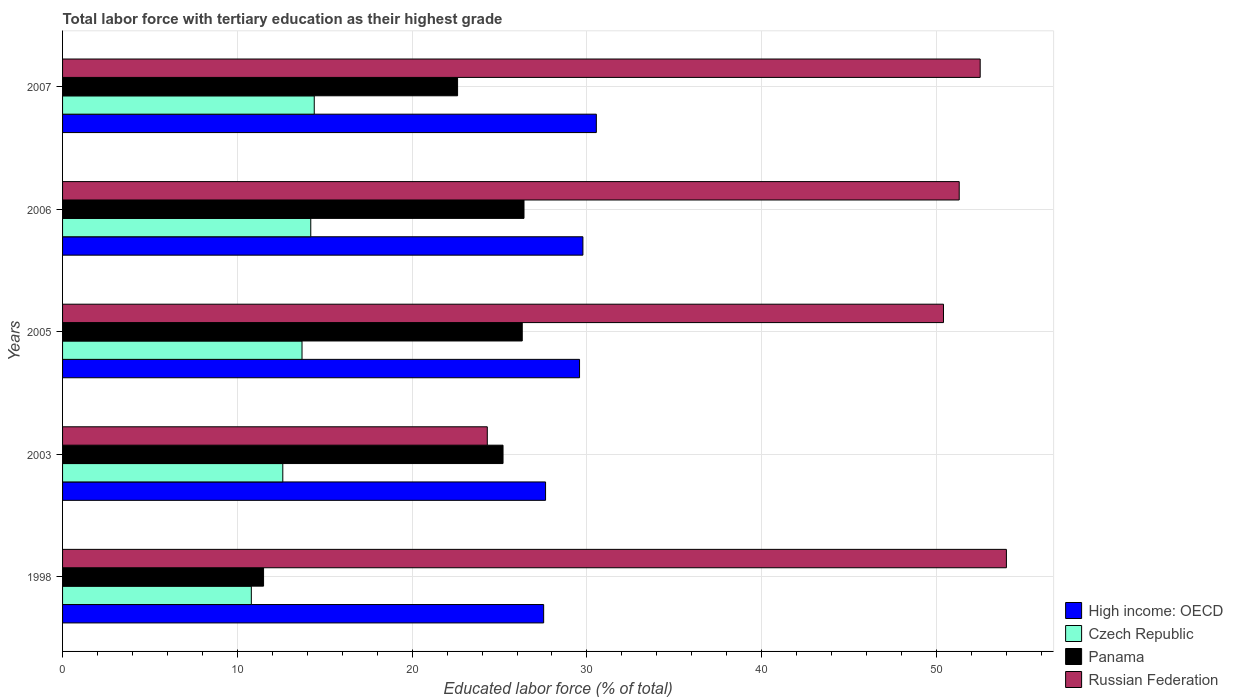How many different coloured bars are there?
Your response must be concise. 4. Are the number of bars on each tick of the Y-axis equal?
Give a very brief answer. Yes. How many bars are there on the 3rd tick from the top?
Make the answer very short. 4. What is the label of the 4th group of bars from the top?
Your answer should be compact. 2003. What is the percentage of male labor force with tertiary education in Russian Federation in 2006?
Your answer should be very brief. 51.3. Across all years, what is the maximum percentage of male labor force with tertiary education in Panama?
Provide a short and direct response. 26.4. Across all years, what is the minimum percentage of male labor force with tertiary education in Czech Republic?
Provide a succinct answer. 10.8. In which year was the percentage of male labor force with tertiary education in Panama minimum?
Give a very brief answer. 1998. What is the total percentage of male labor force with tertiary education in High income: OECD in the graph?
Ensure brevity in your answer.  145.04. What is the difference between the percentage of male labor force with tertiary education in High income: OECD in 1998 and that in 2006?
Give a very brief answer. -2.25. What is the difference between the percentage of male labor force with tertiary education in Panama in 2006 and the percentage of male labor force with tertiary education in Czech Republic in 2005?
Give a very brief answer. 12.7. What is the average percentage of male labor force with tertiary education in Czech Republic per year?
Ensure brevity in your answer.  13.14. In the year 1998, what is the difference between the percentage of male labor force with tertiary education in Panama and percentage of male labor force with tertiary education in Russian Federation?
Offer a very short reply. -42.5. What is the ratio of the percentage of male labor force with tertiary education in Russian Federation in 2003 to that in 2006?
Make the answer very short. 0.47. Is the percentage of male labor force with tertiary education in Czech Republic in 1998 less than that in 2005?
Your answer should be compact. Yes. Is the difference between the percentage of male labor force with tertiary education in Panama in 1998 and 2006 greater than the difference between the percentage of male labor force with tertiary education in Russian Federation in 1998 and 2006?
Your response must be concise. No. What is the difference between the highest and the second highest percentage of male labor force with tertiary education in Czech Republic?
Offer a very short reply. 0.2. What is the difference between the highest and the lowest percentage of male labor force with tertiary education in Czech Republic?
Provide a succinct answer. 3.6. Is the sum of the percentage of male labor force with tertiary education in Russian Federation in 2003 and 2007 greater than the maximum percentage of male labor force with tertiary education in Czech Republic across all years?
Your response must be concise. Yes. Is it the case that in every year, the sum of the percentage of male labor force with tertiary education in Panama and percentage of male labor force with tertiary education in High income: OECD is greater than the sum of percentage of male labor force with tertiary education in Russian Federation and percentage of male labor force with tertiary education in Czech Republic?
Ensure brevity in your answer.  No. What does the 2nd bar from the top in 2005 represents?
Offer a very short reply. Panama. What does the 2nd bar from the bottom in 2003 represents?
Provide a succinct answer. Czech Republic. Is it the case that in every year, the sum of the percentage of male labor force with tertiary education in Czech Republic and percentage of male labor force with tertiary education in Russian Federation is greater than the percentage of male labor force with tertiary education in High income: OECD?
Provide a short and direct response. Yes. How many years are there in the graph?
Give a very brief answer. 5. Where does the legend appear in the graph?
Ensure brevity in your answer.  Bottom right. How many legend labels are there?
Offer a very short reply. 4. How are the legend labels stacked?
Provide a short and direct response. Vertical. What is the title of the graph?
Provide a succinct answer. Total labor force with tertiary education as their highest grade. Does "St. Lucia" appear as one of the legend labels in the graph?
Provide a succinct answer. No. What is the label or title of the X-axis?
Make the answer very short. Educated labor force (% of total). What is the label or title of the Y-axis?
Offer a terse response. Years. What is the Educated labor force (% of total) in High income: OECD in 1998?
Ensure brevity in your answer.  27.52. What is the Educated labor force (% of total) in Czech Republic in 1998?
Keep it short and to the point. 10.8. What is the Educated labor force (% of total) in Panama in 1998?
Your response must be concise. 11.5. What is the Educated labor force (% of total) of Russian Federation in 1998?
Make the answer very short. 54. What is the Educated labor force (% of total) in High income: OECD in 2003?
Provide a short and direct response. 27.63. What is the Educated labor force (% of total) of Czech Republic in 2003?
Provide a short and direct response. 12.6. What is the Educated labor force (% of total) of Panama in 2003?
Provide a short and direct response. 25.2. What is the Educated labor force (% of total) of Russian Federation in 2003?
Make the answer very short. 24.3. What is the Educated labor force (% of total) in High income: OECD in 2005?
Offer a terse response. 29.58. What is the Educated labor force (% of total) in Czech Republic in 2005?
Provide a succinct answer. 13.7. What is the Educated labor force (% of total) of Panama in 2005?
Make the answer very short. 26.3. What is the Educated labor force (% of total) in Russian Federation in 2005?
Offer a terse response. 50.4. What is the Educated labor force (% of total) of High income: OECD in 2006?
Make the answer very short. 29.77. What is the Educated labor force (% of total) in Czech Republic in 2006?
Make the answer very short. 14.2. What is the Educated labor force (% of total) of Panama in 2006?
Your response must be concise. 26.4. What is the Educated labor force (% of total) of Russian Federation in 2006?
Provide a short and direct response. 51.3. What is the Educated labor force (% of total) in High income: OECD in 2007?
Offer a terse response. 30.54. What is the Educated labor force (% of total) of Czech Republic in 2007?
Ensure brevity in your answer.  14.4. What is the Educated labor force (% of total) of Panama in 2007?
Keep it short and to the point. 22.6. What is the Educated labor force (% of total) of Russian Federation in 2007?
Your response must be concise. 52.5. Across all years, what is the maximum Educated labor force (% of total) in High income: OECD?
Provide a succinct answer. 30.54. Across all years, what is the maximum Educated labor force (% of total) in Czech Republic?
Your answer should be compact. 14.4. Across all years, what is the maximum Educated labor force (% of total) in Panama?
Your answer should be very brief. 26.4. Across all years, what is the maximum Educated labor force (% of total) in Russian Federation?
Your answer should be very brief. 54. Across all years, what is the minimum Educated labor force (% of total) in High income: OECD?
Provide a succinct answer. 27.52. Across all years, what is the minimum Educated labor force (% of total) in Czech Republic?
Your response must be concise. 10.8. Across all years, what is the minimum Educated labor force (% of total) of Russian Federation?
Provide a short and direct response. 24.3. What is the total Educated labor force (% of total) of High income: OECD in the graph?
Provide a succinct answer. 145.04. What is the total Educated labor force (% of total) of Czech Republic in the graph?
Offer a terse response. 65.7. What is the total Educated labor force (% of total) in Panama in the graph?
Give a very brief answer. 112. What is the total Educated labor force (% of total) of Russian Federation in the graph?
Your answer should be compact. 232.5. What is the difference between the Educated labor force (% of total) of High income: OECD in 1998 and that in 2003?
Your response must be concise. -0.11. What is the difference between the Educated labor force (% of total) of Panama in 1998 and that in 2003?
Your answer should be very brief. -13.7. What is the difference between the Educated labor force (% of total) in Russian Federation in 1998 and that in 2003?
Give a very brief answer. 29.7. What is the difference between the Educated labor force (% of total) in High income: OECD in 1998 and that in 2005?
Offer a very short reply. -2.05. What is the difference between the Educated labor force (% of total) of Czech Republic in 1998 and that in 2005?
Give a very brief answer. -2.9. What is the difference between the Educated labor force (% of total) in Panama in 1998 and that in 2005?
Your answer should be very brief. -14.8. What is the difference between the Educated labor force (% of total) in Russian Federation in 1998 and that in 2005?
Offer a terse response. 3.6. What is the difference between the Educated labor force (% of total) in High income: OECD in 1998 and that in 2006?
Make the answer very short. -2.25. What is the difference between the Educated labor force (% of total) of Panama in 1998 and that in 2006?
Make the answer very short. -14.9. What is the difference between the Educated labor force (% of total) of High income: OECD in 1998 and that in 2007?
Provide a succinct answer. -3.01. What is the difference between the Educated labor force (% of total) of High income: OECD in 2003 and that in 2005?
Provide a succinct answer. -1.94. What is the difference between the Educated labor force (% of total) of Panama in 2003 and that in 2005?
Keep it short and to the point. -1.1. What is the difference between the Educated labor force (% of total) of Russian Federation in 2003 and that in 2005?
Ensure brevity in your answer.  -26.1. What is the difference between the Educated labor force (% of total) of High income: OECD in 2003 and that in 2006?
Make the answer very short. -2.14. What is the difference between the Educated labor force (% of total) of Czech Republic in 2003 and that in 2006?
Provide a succinct answer. -1.6. What is the difference between the Educated labor force (% of total) of Russian Federation in 2003 and that in 2006?
Offer a very short reply. -27. What is the difference between the Educated labor force (% of total) in High income: OECD in 2003 and that in 2007?
Make the answer very short. -2.9. What is the difference between the Educated labor force (% of total) in Czech Republic in 2003 and that in 2007?
Your answer should be very brief. -1.8. What is the difference between the Educated labor force (% of total) in Panama in 2003 and that in 2007?
Offer a terse response. 2.6. What is the difference between the Educated labor force (% of total) in Russian Federation in 2003 and that in 2007?
Make the answer very short. -28.2. What is the difference between the Educated labor force (% of total) of High income: OECD in 2005 and that in 2006?
Your answer should be compact. -0.19. What is the difference between the Educated labor force (% of total) of Czech Republic in 2005 and that in 2006?
Provide a short and direct response. -0.5. What is the difference between the Educated labor force (% of total) in Panama in 2005 and that in 2006?
Offer a terse response. -0.1. What is the difference between the Educated labor force (% of total) in Russian Federation in 2005 and that in 2006?
Make the answer very short. -0.9. What is the difference between the Educated labor force (% of total) in High income: OECD in 2005 and that in 2007?
Give a very brief answer. -0.96. What is the difference between the Educated labor force (% of total) in Czech Republic in 2005 and that in 2007?
Keep it short and to the point. -0.7. What is the difference between the Educated labor force (% of total) of Panama in 2005 and that in 2007?
Give a very brief answer. 3.7. What is the difference between the Educated labor force (% of total) in Russian Federation in 2005 and that in 2007?
Offer a very short reply. -2.1. What is the difference between the Educated labor force (% of total) in High income: OECD in 2006 and that in 2007?
Your answer should be very brief. -0.77. What is the difference between the Educated labor force (% of total) in Czech Republic in 2006 and that in 2007?
Your answer should be very brief. -0.2. What is the difference between the Educated labor force (% of total) of Panama in 2006 and that in 2007?
Keep it short and to the point. 3.8. What is the difference between the Educated labor force (% of total) of Russian Federation in 2006 and that in 2007?
Make the answer very short. -1.2. What is the difference between the Educated labor force (% of total) of High income: OECD in 1998 and the Educated labor force (% of total) of Czech Republic in 2003?
Provide a short and direct response. 14.92. What is the difference between the Educated labor force (% of total) in High income: OECD in 1998 and the Educated labor force (% of total) in Panama in 2003?
Offer a very short reply. 2.32. What is the difference between the Educated labor force (% of total) of High income: OECD in 1998 and the Educated labor force (% of total) of Russian Federation in 2003?
Make the answer very short. 3.22. What is the difference between the Educated labor force (% of total) of Czech Republic in 1998 and the Educated labor force (% of total) of Panama in 2003?
Ensure brevity in your answer.  -14.4. What is the difference between the Educated labor force (% of total) of High income: OECD in 1998 and the Educated labor force (% of total) of Czech Republic in 2005?
Offer a terse response. 13.82. What is the difference between the Educated labor force (% of total) in High income: OECD in 1998 and the Educated labor force (% of total) in Panama in 2005?
Offer a terse response. 1.22. What is the difference between the Educated labor force (% of total) of High income: OECD in 1998 and the Educated labor force (% of total) of Russian Federation in 2005?
Provide a succinct answer. -22.88. What is the difference between the Educated labor force (% of total) of Czech Republic in 1998 and the Educated labor force (% of total) of Panama in 2005?
Provide a succinct answer. -15.5. What is the difference between the Educated labor force (% of total) of Czech Republic in 1998 and the Educated labor force (% of total) of Russian Federation in 2005?
Your response must be concise. -39.6. What is the difference between the Educated labor force (% of total) of Panama in 1998 and the Educated labor force (% of total) of Russian Federation in 2005?
Provide a short and direct response. -38.9. What is the difference between the Educated labor force (% of total) of High income: OECD in 1998 and the Educated labor force (% of total) of Czech Republic in 2006?
Provide a succinct answer. 13.32. What is the difference between the Educated labor force (% of total) of High income: OECD in 1998 and the Educated labor force (% of total) of Panama in 2006?
Ensure brevity in your answer.  1.12. What is the difference between the Educated labor force (% of total) in High income: OECD in 1998 and the Educated labor force (% of total) in Russian Federation in 2006?
Make the answer very short. -23.78. What is the difference between the Educated labor force (% of total) in Czech Republic in 1998 and the Educated labor force (% of total) in Panama in 2006?
Provide a succinct answer. -15.6. What is the difference between the Educated labor force (% of total) of Czech Republic in 1998 and the Educated labor force (% of total) of Russian Federation in 2006?
Keep it short and to the point. -40.5. What is the difference between the Educated labor force (% of total) in Panama in 1998 and the Educated labor force (% of total) in Russian Federation in 2006?
Ensure brevity in your answer.  -39.8. What is the difference between the Educated labor force (% of total) of High income: OECD in 1998 and the Educated labor force (% of total) of Czech Republic in 2007?
Provide a short and direct response. 13.12. What is the difference between the Educated labor force (% of total) of High income: OECD in 1998 and the Educated labor force (% of total) of Panama in 2007?
Ensure brevity in your answer.  4.92. What is the difference between the Educated labor force (% of total) in High income: OECD in 1998 and the Educated labor force (% of total) in Russian Federation in 2007?
Provide a succinct answer. -24.98. What is the difference between the Educated labor force (% of total) in Czech Republic in 1998 and the Educated labor force (% of total) in Russian Federation in 2007?
Your answer should be very brief. -41.7. What is the difference between the Educated labor force (% of total) in Panama in 1998 and the Educated labor force (% of total) in Russian Federation in 2007?
Your answer should be compact. -41. What is the difference between the Educated labor force (% of total) of High income: OECD in 2003 and the Educated labor force (% of total) of Czech Republic in 2005?
Give a very brief answer. 13.93. What is the difference between the Educated labor force (% of total) of High income: OECD in 2003 and the Educated labor force (% of total) of Panama in 2005?
Keep it short and to the point. 1.33. What is the difference between the Educated labor force (% of total) of High income: OECD in 2003 and the Educated labor force (% of total) of Russian Federation in 2005?
Your answer should be compact. -22.77. What is the difference between the Educated labor force (% of total) of Czech Republic in 2003 and the Educated labor force (% of total) of Panama in 2005?
Make the answer very short. -13.7. What is the difference between the Educated labor force (% of total) in Czech Republic in 2003 and the Educated labor force (% of total) in Russian Federation in 2005?
Provide a succinct answer. -37.8. What is the difference between the Educated labor force (% of total) in Panama in 2003 and the Educated labor force (% of total) in Russian Federation in 2005?
Ensure brevity in your answer.  -25.2. What is the difference between the Educated labor force (% of total) in High income: OECD in 2003 and the Educated labor force (% of total) in Czech Republic in 2006?
Your response must be concise. 13.43. What is the difference between the Educated labor force (% of total) in High income: OECD in 2003 and the Educated labor force (% of total) in Panama in 2006?
Offer a terse response. 1.23. What is the difference between the Educated labor force (% of total) of High income: OECD in 2003 and the Educated labor force (% of total) of Russian Federation in 2006?
Offer a very short reply. -23.67. What is the difference between the Educated labor force (% of total) in Czech Republic in 2003 and the Educated labor force (% of total) in Panama in 2006?
Your answer should be very brief. -13.8. What is the difference between the Educated labor force (% of total) in Czech Republic in 2003 and the Educated labor force (% of total) in Russian Federation in 2006?
Provide a succinct answer. -38.7. What is the difference between the Educated labor force (% of total) of Panama in 2003 and the Educated labor force (% of total) of Russian Federation in 2006?
Your answer should be very brief. -26.1. What is the difference between the Educated labor force (% of total) of High income: OECD in 2003 and the Educated labor force (% of total) of Czech Republic in 2007?
Provide a short and direct response. 13.23. What is the difference between the Educated labor force (% of total) in High income: OECD in 2003 and the Educated labor force (% of total) in Panama in 2007?
Offer a very short reply. 5.03. What is the difference between the Educated labor force (% of total) of High income: OECD in 2003 and the Educated labor force (% of total) of Russian Federation in 2007?
Your response must be concise. -24.87. What is the difference between the Educated labor force (% of total) of Czech Republic in 2003 and the Educated labor force (% of total) of Russian Federation in 2007?
Give a very brief answer. -39.9. What is the difference between the Educated labor force (% of total) of Panama in 2003 and the Educated labor force (% of total) of Russian Federation in 2007?
Your response must be concise. -27.3. What is the difference between the Educated labor force (% of total) in High income: OECD in 2005 and the Educated labor force (% of total) in Czech Republic in 2006?
Provide a short and direct response. 15.38. What is the difference between the Educated labor force (% of total) of High income: OECD in 2005 and the Educated labor force (% of total) of Panama in 2006?
Your answer should be very brief. 3.18. What is the difference between the Educated labor force (% of total) of High income: OECD in 2005 and the Educated labor force (% of total) of Russian Federation in 2006?
Offer a terse response. -21.72. What is the difference between the Educated labor force (% of total) of Czech Republic in 2005 and the Educated labor force (% of total) of Panama in 2006?
Ensure brevity in your answer.  -12.7. What is the difference between the Educated labor force (% of total) in Czech Republic in 2005 and the Educated labor force (% of total) in Russian Federation in 2006?
Make the answer very short. -37.6. What is the difference between the Educated labor force (% of total) of High income: OECD in 2005 and the Educated labor force (% of total) of Czech Republic in 2007?
Offer a terse response. 15.18. What is the difference between the Educated labor force (% of total) of High income: OECD in 2005 and the Educated labor force (% of total) of Panama in 2007?
Your answer should be compact. 6.98. What is the difference between the Educated labor force (% of total) of High income: OECD in 2005 and the Educated labor force (% of total) of Russian Federation in 2007?
Ensure brevity in your answer.  -22.92. What is the difference between the Educated labor force (% of total) of Czech Republic in 2005 and the Educated labor force (% of total) of Russian Federation in 2007?
Offer a terse response. -38.8. What is the difference between the Educated labor force (% of total) in Panama in 2005 and the Educated labor force (% of total) in Russian Federation in 2007?
Provide a short and direct response. -26.2. What is the difference between the Educated labor force (% of total) of High income: OECD in 2006 and the Educated labor force (% of total) of Czech Republic in 2007?
Provide a short and direct response. 15.37. What is the difference between the Educated labor force (% of total) of High income: OECD in 2006 and the Educated labor force (% of total) of Panama in 2007?
Give a very brief answer. 7.17. What is the difference between the Educated labor force (% of total) in High income: OECD in 2006 and the Educated labor force (% of total) in Russian Federation in 2007?
Offer a terse response. -22.73. What is the difference between the Educated labor force (% of total) of Czech Republic in 2006 and the Educated labor force (% of total) of Panama in 2007?
Provide a succinct answer. -8.4. What is the difference between the Educated labor force (% of total) in Czech Republic in 2006 and the Educated labor force (% of total) in Russian Federation in 2007?
Provide a succinct answer. -38.3. What is the difference between the Educated labor force (% of total) in Panama in 2006 and the Educated labor force (% of total) in Russian Federation in 2007?
Offer a very short reply. -26.1. What is the average Educated labor force (% of total) in High income: OECD per year?
Your response must be concise. 29.01. What is the average Educated labor force (% of total) of Czech Republic per year?
Provide a short and direct response. 13.14. What is the average Educated labor force (% of total) of Panama per year?
Your response must be concise. 22.4. What is the average Educated labor force (% of total) of Russian Federation per year?
Your response must be concise. 46.5. In the year 1998, what is the difference between the Educated labor force (% of total) of High income: OECD and Educated labor force (% of total) of Czech Republic?
Your answer should be very brief. 16.72. In the year 1998, what is the difference between the Educated labor force (% of total) in High income: OECD and Educated labor force (% of total) in Panama?
Make the answer very short. 16.02. In the year 1998, what is the difference between the Educated labor force (% of total) of High income: OECD and Educated labor force (% of total) of Russian Federation?
Your response must be concise. -26.48. In the year 1998, what is the difference between the Educated labor force (% of total) of Czech Republic and Educated labor force (% of total) of Panama?
Provide a succinct answer. -0.7. In the year 1998, what is the difference between the Educated labor force (% of total) of Czech Republic and Educated labor force (% of total) of Russian Federation?
Ensure brevity in your answer.  -43.2. In the year 1998, what is the difference between the Educated labor force (% of total) in Panama and Educated labor force (% of total) in Russian Federation?
Offer a terse response. -42.5. In the year 2003, what is the difference between the Educated labor force (% of total) of High income: OECD and Educated labor force (% of total) of Czech Republic?
Give a very brief answer. 15.03. In the year 2003, what is the difference between the Educated labor force (% of total) in High income: OECD and Educated labor force (% of total) in Panama?
Give a very brief answer. 2.43. In the year 2003, what is the difference between the Educated labor force (% of total) in High income: OECD and Educated labor force (% of total) in Russian Federation?
Ensure brevity in your answer.  3.33. In the year 2003, what is the difference between the Educated labor force (% of total) in Czech Republic and Educated labor force (% of total) in Panama?
Offer a terse response. -12.6. In the year 2003, what is the difference between the Educated labor force (% of total) of Czech Republic and Educated labor force (% of total) of Russian Federation?
Your answer should be compact. -11.7. In the year 2005, what is the difference between the Educated labor force (% of total) in High income: OECD and Educated labor force (% of total) in Czech Republic?
Keep it short and to the point. 15.88. In the year 2005, what is the difference between the Educated labor force (% of total) of High income: OECD and Educated labor force (% of total) of Panama?
Keep it short and to the point. 3.28. In the year 2005, what is the difference between the Educated labor force (% of total) of High income: OECD and Educated labor force (% of total) of Russian Federation?
Make the answer very short. -20.82. In the year 2005, what is the difference between the Educated labor force (% of total) of Czech Republic and Educated labor force (% of total) of Panama?
Give a very brief answer. -12.6. In the year 2005, what is the difference between the Educated labor force (% of total) of Czech Republic and Educated labor force (% of total) of Russian Federation?
Offer a very short reply. -36.7. In the year 2005, what is the difference between the Educated labor force (% of total) of Panama and Educated labor force (% of total) of Russian Federation?
Provide a short and direct response. -24.1. In the year 2006, what is the difference between the Educated labor force (% of total) in High income: OECD and Educated labor force (% of total) in Czech Republic?
Provide a succinct answer. 15.57. In the year 2006, what is the difference between the Educated labor force (% of total) in High income: OECD and Educated labor force (% of total) in Panama?
Provide a succinct answer. 3.37. In the year 2006, what is the difference between the Educated labor force (% of total) of High income: OECD and Educated labor force (% of total) of Russian Federation?
Your response must be concise. -21.53. In the year 2006, what is the difference between the Educated labor force (% of total) in Czech Republic and Educated labor force (% of total) in Russian Federation?
Your answer should be compact. -37.1. In the year 2006, what is the difference between the Educated labor force (% of total) of Panama and Educated labor force (% of total) of Russian Federation?
Ensure brevity in your answer.  -24.9. In the year 2007, what is the difference between the Educated labor force (% of total) of High income: OECD and Educated labor force (% of total) of Czech Republic?
Offer a terse response. 16.14. In the year 2007, what is the difference between the Educated labor force (% of total) in High income: OECD and Educated labor force (% of total) in Panama?
Give a very brief answer. 7.94. In the year 2007, what is the difference between the Educated labor force (% of total) of High income: OECD and Educated labor force (% of total) of Russian Federation?
Offer a very short reply. -21.96. In the year 2007, what is the difference between the Educated labor force (% of total) in Czech Republic and Educated labor force (% of total) in Russian Federation?
Give a very brief answer. -38.1. In the year 2007, what is the difference between the Educated labor force (% of total) of Panama and Educated labor force (% of total) of Russian Federation?
Provide a short and direct response. -29.9. What is the ratio of the Educated labor force (% of total) in Panama in 1998 to that in 2003?
Ensure brevity in your answer.  0.46. What is the ratio of the Educated labor force (% of total) in Russian Federation in 1998 to that in 2003?
Your answer should be very brief. 2.22. What is the ratio of the Educated labor force (% of total) in High income: OECD in 1998 to that in 2005?
Provide a succinct answer. 0.93. What is the ratio of the Educated labor force (% of total) of Czech Republic in 1998 to that in 2005?
Ensure brevity in your answer.  0.79. What is the ratio of the Educated labor force (% of total) of Panama in 1998 to that in 2005?
Ensure brevity in your answer.  0.44. What is the ratio of the Educated labor force (% of total) in Russian Federation in 1998 to that in 2005?
Offer a very short reply. 1.07. What is the ratio of the Educated labor force (% of total) of High income: OECD in 1998 to that in 2006?
Give a very brief answer. 0.92. What is the ratio of the Educated labor force (% of total) of Czech Republic in 1998 to that in 2006?
Make the answer very short. 0.76. What is the ratio of the Educated labor force (% of total) in Panama in 1998 to that in 2006?
Offer a terse response. 0.44. What is the ratio of the Educated labor force (% of total) in Russian Federation in 1998 to that in 2006?
Your response must be concise. 1.05. What is the ratio of the Educated labor force (% of total) in High income: OECD in 1998 to that in 2007?
Provide a short and direct response. 0.9. What is the ratio of the Educated labor force (% of total) in Panama in 1998 to that in 2007?
Offer a very short reply. 0.51. What is the ratio of the Educated labor force (% of total) of Russian Federation in 1998 to that in 2007?
Your answer should be very brief. 1.03. What is the ratio of the Educated labor force (% of total) in High income: OECD in 2003 to that in 2005?
Offer a terse response. 0.93. What is the ratio of the Educated labor force (% of total) in Czech Republic in 2003 to that in 2005?
Ensure brevity in your answer.  0.92. What is the ratio of the Educated labor force (% of total) in Panama in 2003 to that in 2005?
Provide a short and direct response. 0.96. What is the ratio of the Educated labor force (% of total) in Russian Federation in 2003 to that in 2005?
Provide a short and direct response. 0.48. What is the ratio of the Educated labor force (% of total) of High income: OECD in 2003 to that in 2006?
Give a very brief answer. 0.93. What is the ratio of the Educated labor force (% of total) of Czech Republic in 2003 to that in 2006?
Provide a succinct answer. 0.89. What is the ratio of the Educated labor force (% of total) of Panama in 2003 to that in 2006?
Your response must be concise. 0.95. What is the ratio of the Educated labor force (% of total) in Russian Federation in 2003 to that in 2006?
Your answer should be compact. 0.47. What is the ratio of the Educated labor force (% of total) of High income: OECD in 2003 to that in 2007?
Offer a very short reply. 0.9. What is the ratio of the Educated labor force (% of total) in Czech Republic in 2003 to that in 2007?
Give a very brief answer. 0.88. What is the ratio of the Educated labor force (% of total) in Panama in 2003 to that in 2007?
Your answer should be compact. 1.11. What is the ratio of the Educated labor force (% of total) in Russian Federation in 2003 to that in 2007?
Your response must be concise. 0.46. What is the ratio of the Educated labor force (% of total) in Czech Republic in 2005 to that in 2006?
Provide a succinct answer. 0.96. What is the ratio of the Educated labor force (% of total) in Panama in 2005 to that in 2006?
Keep it short and to the point. 1. What is the ratio of the Educated labor force (% of total) of Russian Federation in 2005 to that in 2006?
Ensure brevity in your answer.  0.98. What is the ratio of the Educated labor force (% of total) in High income: OECD in 2005 to that in 2007?
Give a very brief answer. 0.97. What is the ratio of the Educated labor force (% of total) in Czech Republic in 2005 to that in 2007?
Make the answer very short. 0.95. What is the ratio of the Educated labor force (% of total) in Panama in 2005 to that in 2007?
Keep it short and to the point. 1.16. What is the ratio of the Educated labor force (% of total) in High income: OECD in 2006 to that in 2007?
Offer a very short reply. 0.97. What is the ratio of the Educated labor force (% of total) of Czech Republic in 2006 to that in 2007?
Ensure brevity in your answer.  0.99. What is the ratio of the Educated labor force (% of total) of Panama in 2006 to that in 2007?
Make the answer very short. 1.17. What is the ratio of the Educated labor force (% of total) in Russian Federation in 2006 to that in 2007?
Provide a succinct answer. 0.98. What is the difference between the highest and the second highest Educated labor force (% of total) of High income: OECD?
Give a very brief answer. 0.77. What is the difference between the highest and the second highest Educated labor force (% of total) of Czech Republic?
Keep it short and to the point. 0.2. What is the difference between the highest and the lowest Educated labor force (% of total) of High income: OECD?
Provide a short and direct response. 3.01. What is the difference between the highest and the lowest Educated labor force (% of total) of Russian Federation?
Provide a succinct answer. 29.7. 